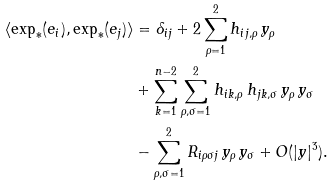<formula> <loc_0><loc_0><loc_500><loc_500>\langle \exp _ { * } ( e _ { i } ) , \exp _ { * } ( e _ { j } ) \rangle & = \delta _ { i j } + 2 \sum _ { \rho = 1 } ^ { 2 } h _ { i j , \rho } \, y _ { \rho } \\ & + \sum _ { k = 1 } ^ { n - 2 } \sum _ { \rho , \sigma = 1 } ^ { 2 } h _ { i k , \rho } \, h _ { j k , \sigma } \, y _ { \rho } \, y _ { \sigma } \\ & - \sum _ { \rho , \sigma = 1 } ^ { 2 } R _ { i \rho \sigma j } \, y _ { \rho } \, y _ { \sigma } + O ( | y | ^ { 3 } ) .</formula> 